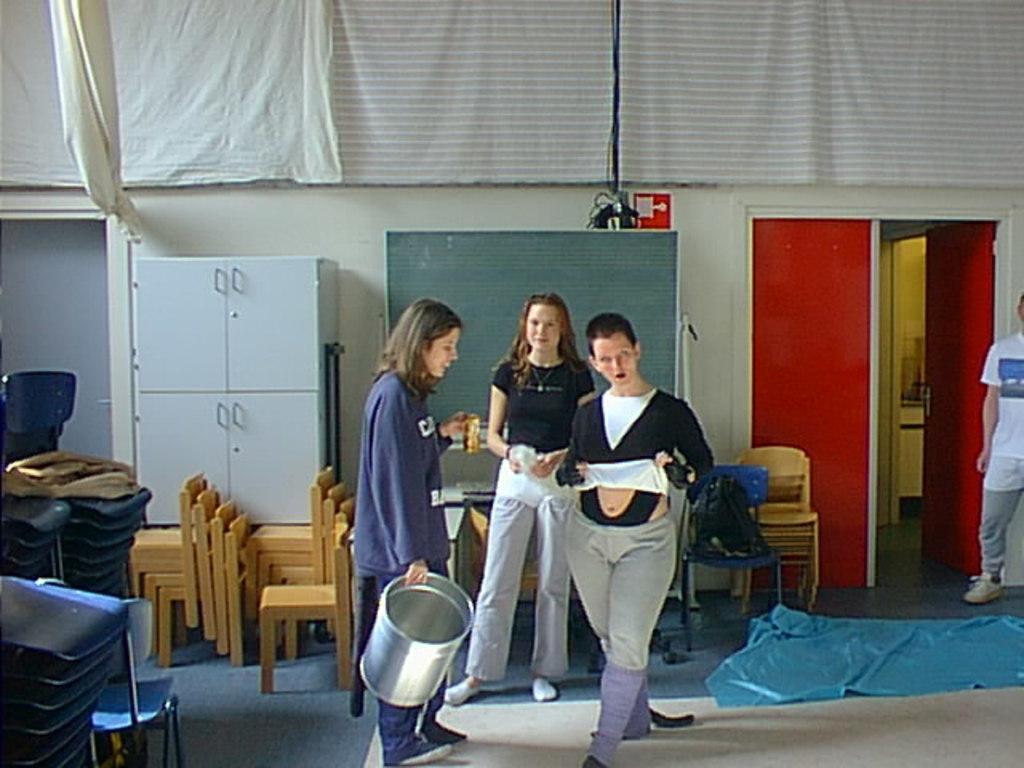Please provide a concise description of this image. In this picture we can see three woman standing, the woman on the left side is holding steel bucket, the woman in the right side is holding cloth, in the background we can see some of chairs and also we can see a cupboard, on the right side of the image we can see a person standing and also there is a door, on the top of the image we can see a cloth covered the wall. 